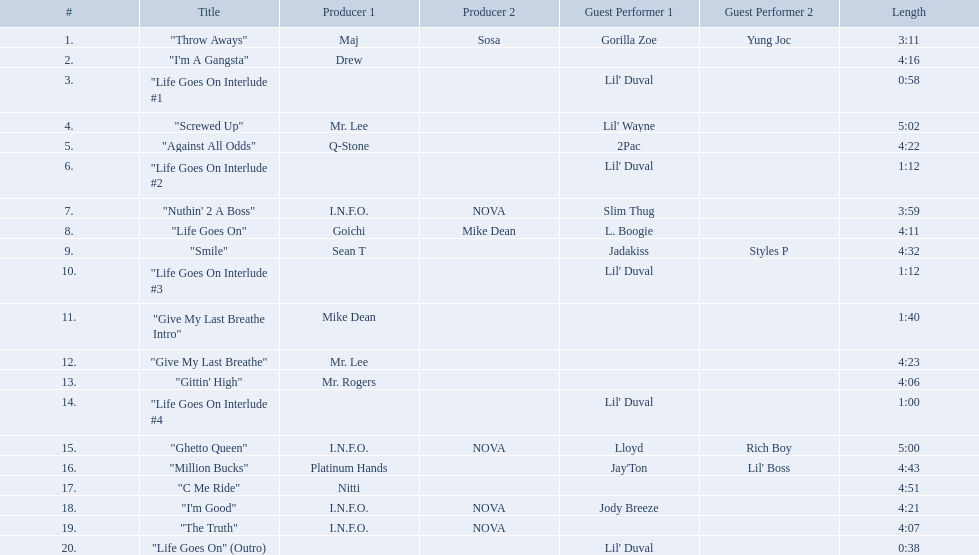Which tracks are longer than 4.00? "I'm A Gangsta", "Screwed Up", "Against All Odds", "Life Goes On", "Smile", "Give My Last Breathe", "Gittin' High", "Ghetto Queen", "Million Bucks", "C Me Ride", "I'm Good", "The Truth". Of those, which tracks are longer than 4.30? "Screwed Up", "Smile", "Ghetto Queen", "Million Bucks", "C Me Ride". Of those, which tracks are 5.00 or longer? "Screwed Up", "Ghetto Queen". Of those, which one is the longest? "Screwed Up". How long is that track? 5:02. 